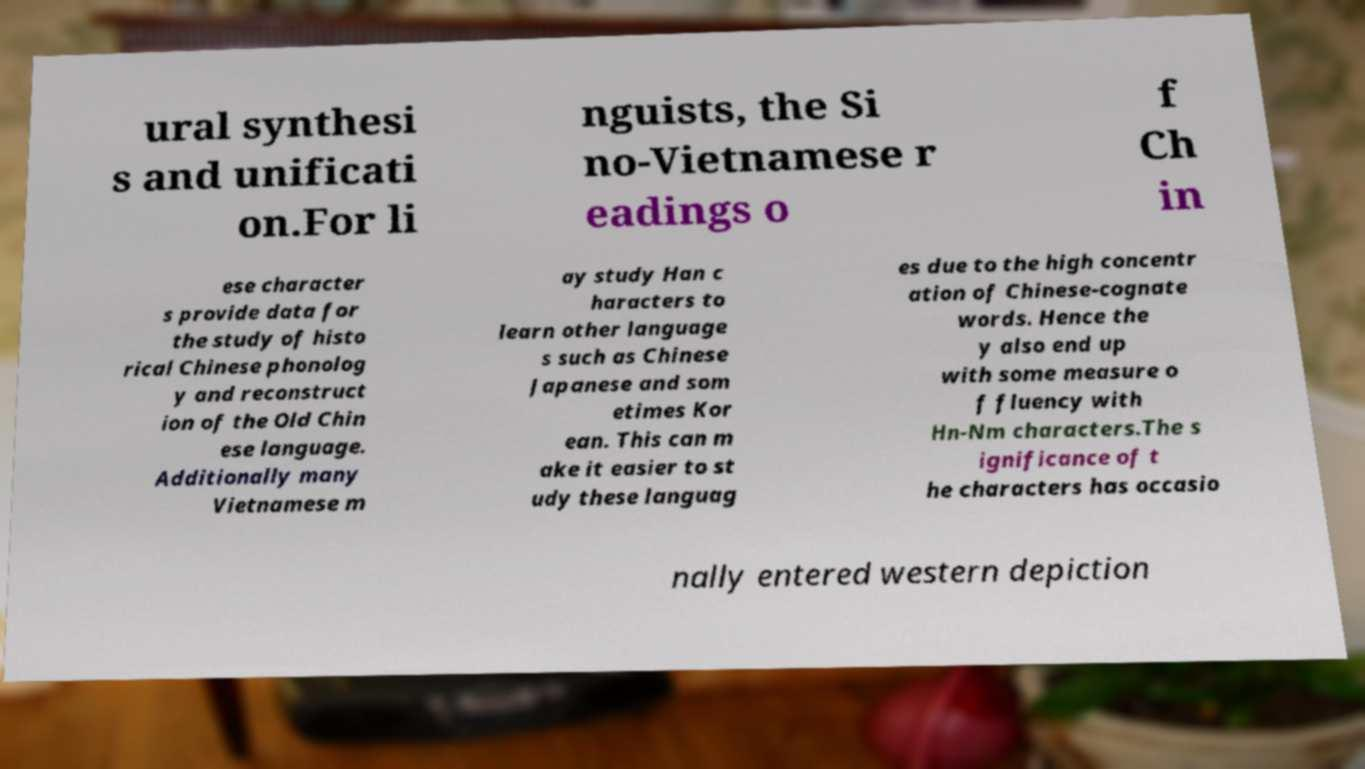Can you accurately transcribe the text from the provided image for me? ural synthesi s and unificati on.For li nguists, the Si no-Vietnamese r eadings o f Ch in ese character s provide data for the study of histo rical Chinese phonolog y and reconstruct ion of the Old Chin ese language. Additionally many Vietnamese m ay study Han c haracters to learn other language s such as Chinese Japanese and som etimes Kor ean. This can m ake it easier to st udy these languag es due to the high concentr ation of Chinese-cognate words. Hence the y also end up with some measure o f fluency with Hn-Nm characters.The s ignificance of t he characters has occasio nally entered western depiction 